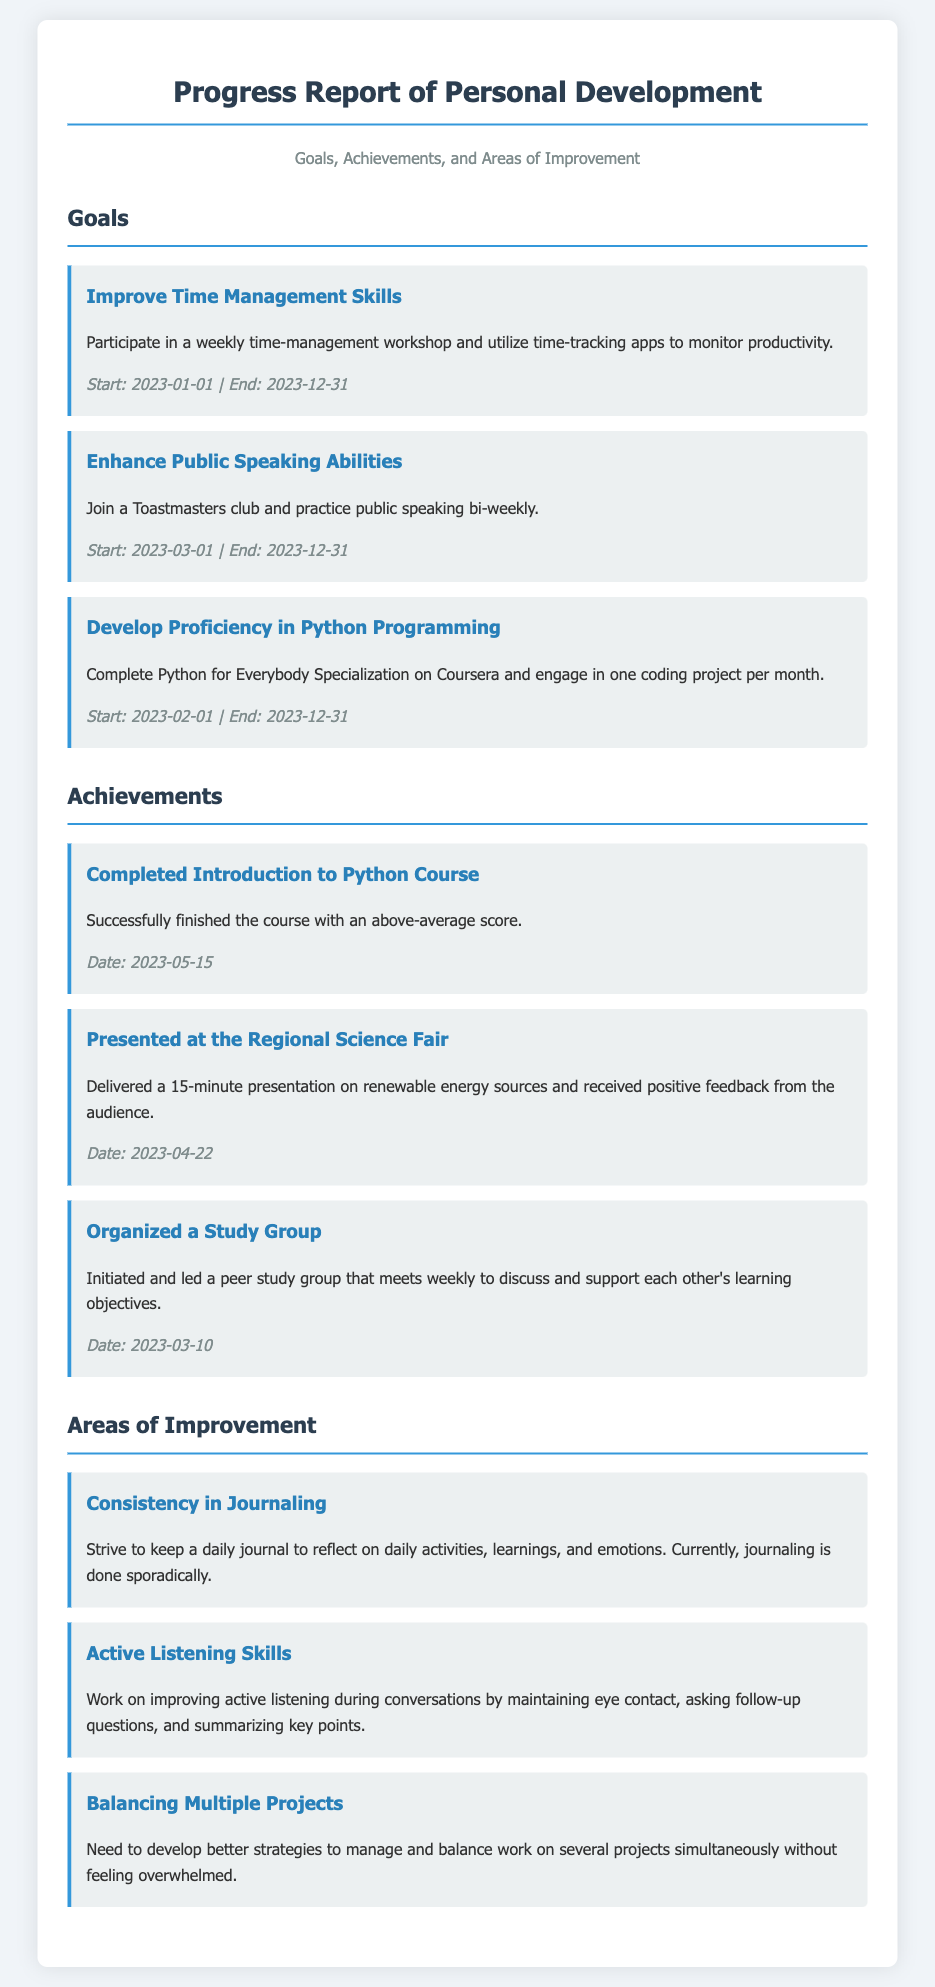what is the duration for improving time management skills? The duration is indicated in the goals section, which specifies the start and end date for this goal.
Answer: 2023-01-01 to 2023-12-31 how many goals are listed in the document? The number of goals can be found in the goals section, where each goal is presented as a separate item.
Answer: 3 when did the individual present at the Regional Science Fair? The date of the presentation is found in the achievements section, specifically noted under that achievement item.
Answer: 2023-04-22 what is one area of improvement mentioned in the report? The document lists specific areas of improvement, which can be found in the corresponding section.
Answer: Consistency in Journaling which course was completed successfully by the individual? The accomplished course is noted in the achievements section under the relevant item, indicating it was completed.
Answer: Introduction to Python Course what skill is being developed through participation in a Toastmasters club? The skill being developed is directly mentioned in the goals section associated with public speaking.
Answer: Public Speaking Abilities how often is the study group scheduled to meet? The frequency of the study group's meetings is mentioned in the achievements section within that item's description.
Answer: Weekly what strategy needs improvement for balancing projects? This need for improvement is stated in the areas of improvement section, focusing on managing multiple projects.
Answer: Strategies to manage projects 